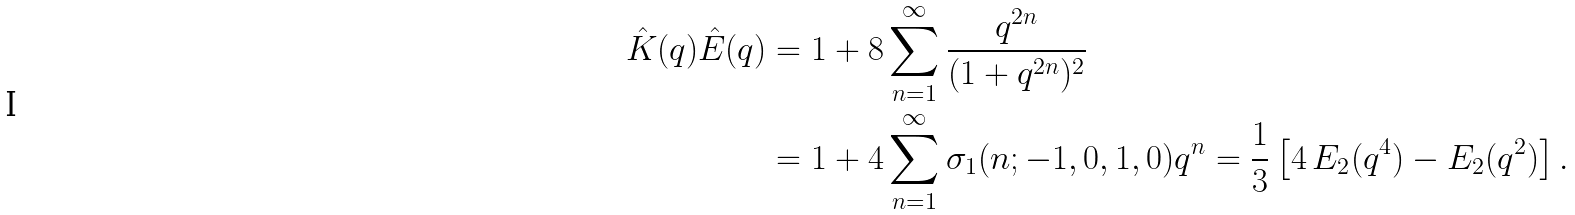Convert formula to latex. <formula><loc_0><loc_0><loc_500><loc_500>\hat { K } ( q ) \hat { E } ( q ) & = 1 + 8 \sum _ { n = 1 } ^ { \infty } \frac { q ^ { 2 n } } { ( 1 + q ^ { 2 n } ) ^ { 2 } } \\ & = 1 + 4 \sum _ { n = 1 } ^ { \infty } \sigma _ { 1 } ( n ; - 1 , 0 , 1 , 0 ) q ^ { n } = \frac { 1 } { 3 } \left [ 4 \, E _ { 2 } ( q ^ { 4 } ) - E _ { 2 } ( q ^ { 2 } ) \right ] .</formula> 